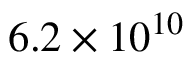Convert formula to latex. <formula><loc_0><loc_0><loc_500><loc_500>6 . 2 \times 1 0 ^ { 1 0 }</formula> 